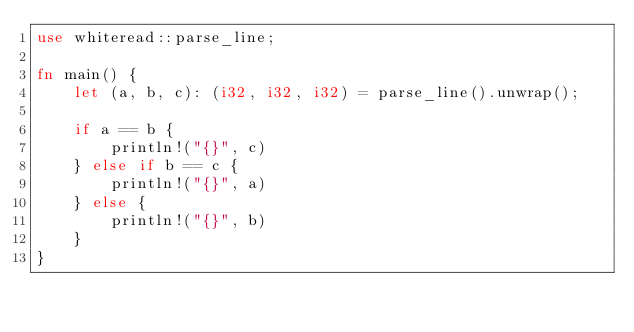<code> <loc_0><loc_0><loc_500><loc_500><_Rust_>use whiteread::parse_line;

fn main() {
    let (a, b, c): (i32, i32, i32) = parse_line().unwrap();
    
    if a == b {
        println!("{}", c)
    } else if b == c {
        println!("{}", a)
    } else {
        println!("{}", b)
    }
}
</code> 